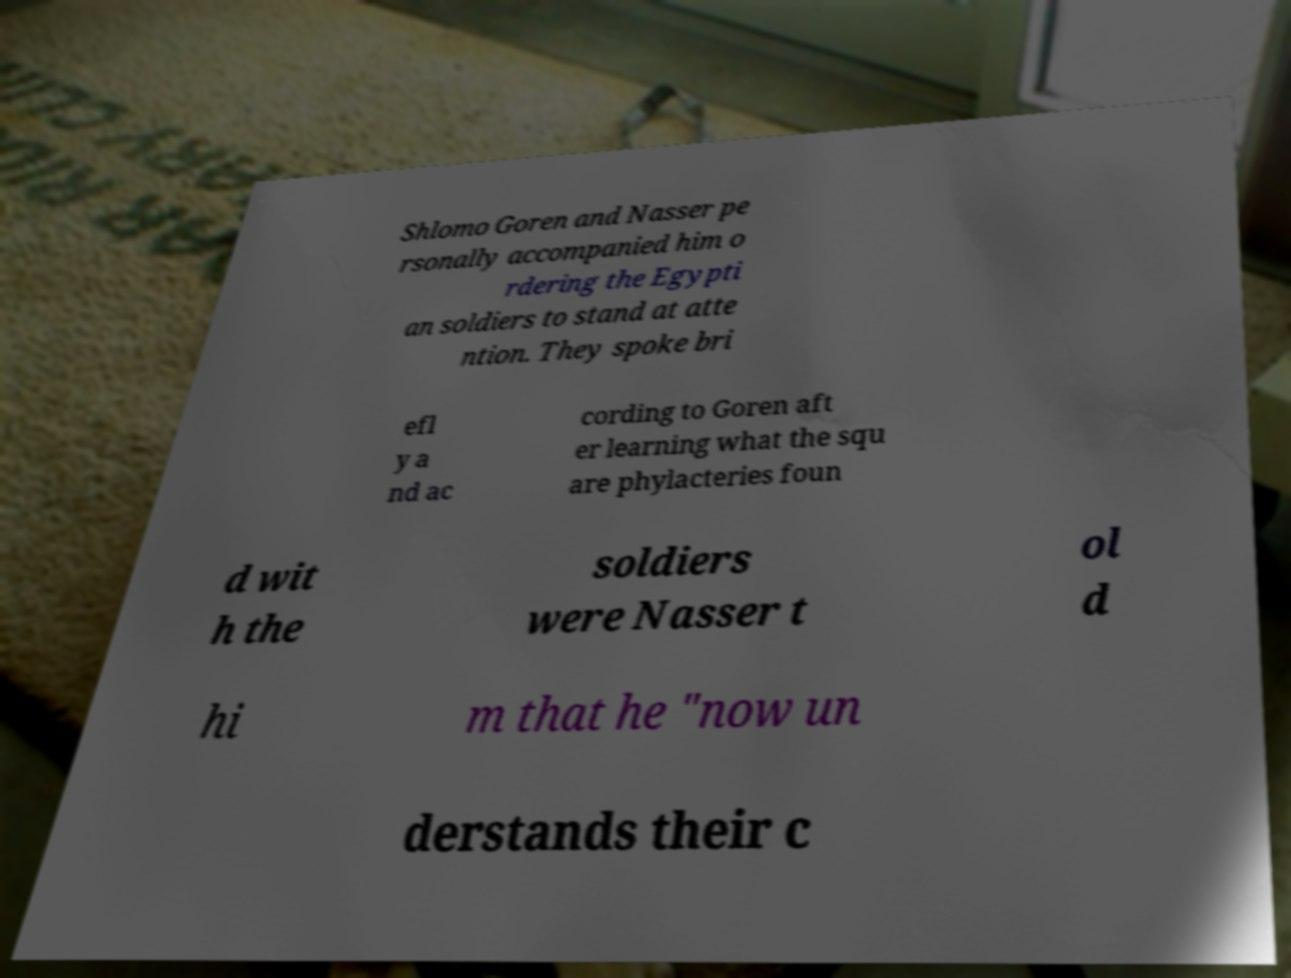What messages or text are displayed in this image? I need them in a readable, typed format. Shlomo Goren and Nasser pe rsonally accompanied him o rdering the Egypti an soldiers to stand at atte ntion. They spoke bri efl y a nd ac cording to Goren aft er learning what the squ are phylacteries foun d wit h the soldiers were Nasser t ol d hi m that he "now un derstands their c 